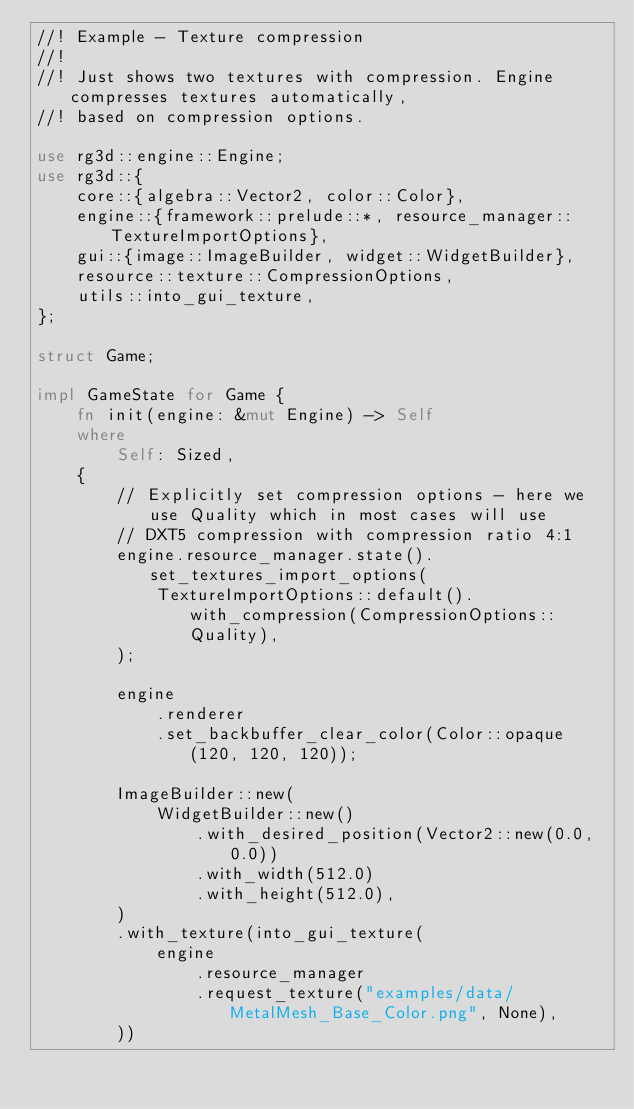<code> <loc_0><loc_0><loc_500><loc_500><_Rust_>//! Example - Texture compression
//!
//! Just shows two textures with compression. Engine compresses textures automatically,
//! based on compression options.

use rg3d::engine::Engine;
use rg3d::{
    core::{algebra::Vector2, color::Color},
    engine::{framework::prelude::*, resource_manager::TextureImportOptions},
    gui::{image::ImageBuilder, widget::WidgetBuilder},
    resource::texture::CompressionOptions,
    utils::into_gui_texture,
};

struct Game;

impl GameState for Game {
    fn init(engine: &mut Engine) -> Self
    where
        Self: Sized,
    {
        // Explicitly set compression options - here we use Quality which in most cases will use
        // DXT5 compression with compression ratio 4:1
        engine.resource_manager.state().set_textures_import_options(
            TextureImportOptions::default().with_compression(CompressionOptions::Quality),
        );

        engine
            .renderer
            .set_backbuffer_clear_color(Color::opaque(120, 120, 120));

        ImageBuilder::new(
            WidgetBuilder::new()
                .with_desired_position(Vector2::new(0.0, 0.0))
                .with_width(512.0)
                .with_height(512.0),
        )
        .with_texture(into_gui_texture(
            engine
                .resource_manager
                .request_texture("examples/data/MetalMesh_Base_Color.png", None),
        ))</code> 